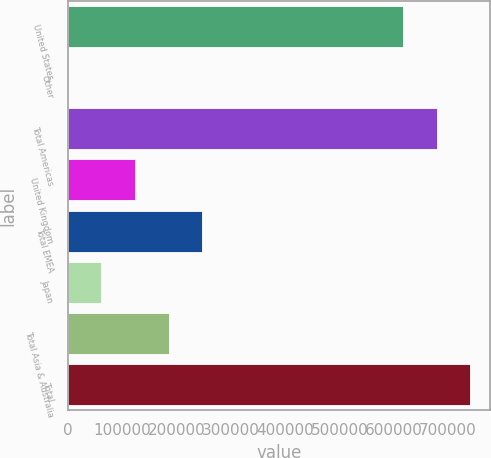Convert chart. <chart><loc_0><loc_0><loc_500><loc_500><bar_chart><fcel>United States<fcel>Other<fcel>Total Americas<fcel>United Kingdom<fcel>Total EMEA<fcel>Japan<fcel>Total Asia & Australia<fcel>Total<nl><fcel>616856<fcel>2<fcel>678883<fcel>124057<fcel>248112<fcel>62029.4<fcel>186084<fcel>740911<nl></chart> 